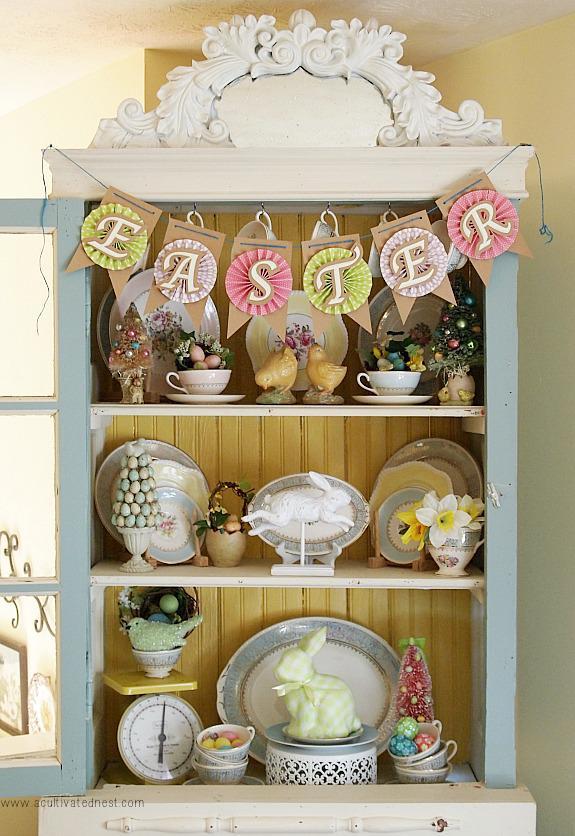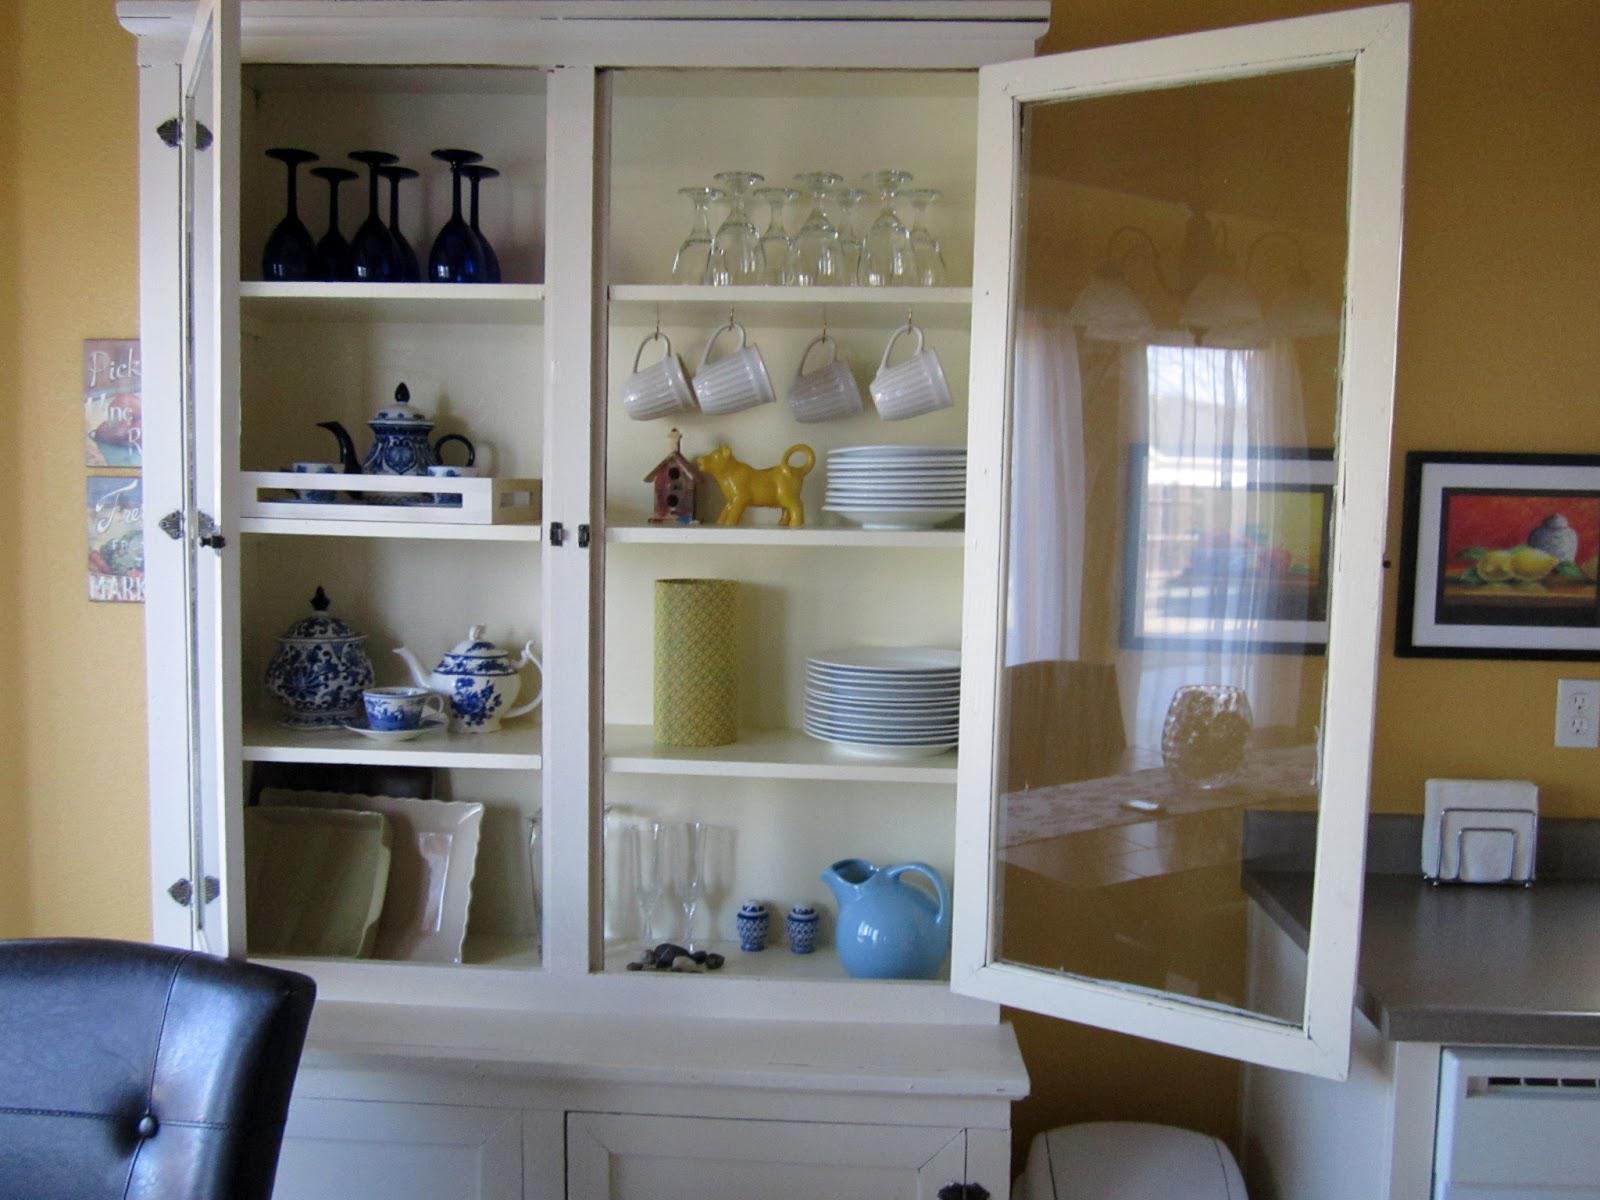The first image is the image on the left, the second image is the image on the right. Assess this claim about the two images: "None of the cabinets are colored red.". Correct or not? Answer yes or no. Yes. 